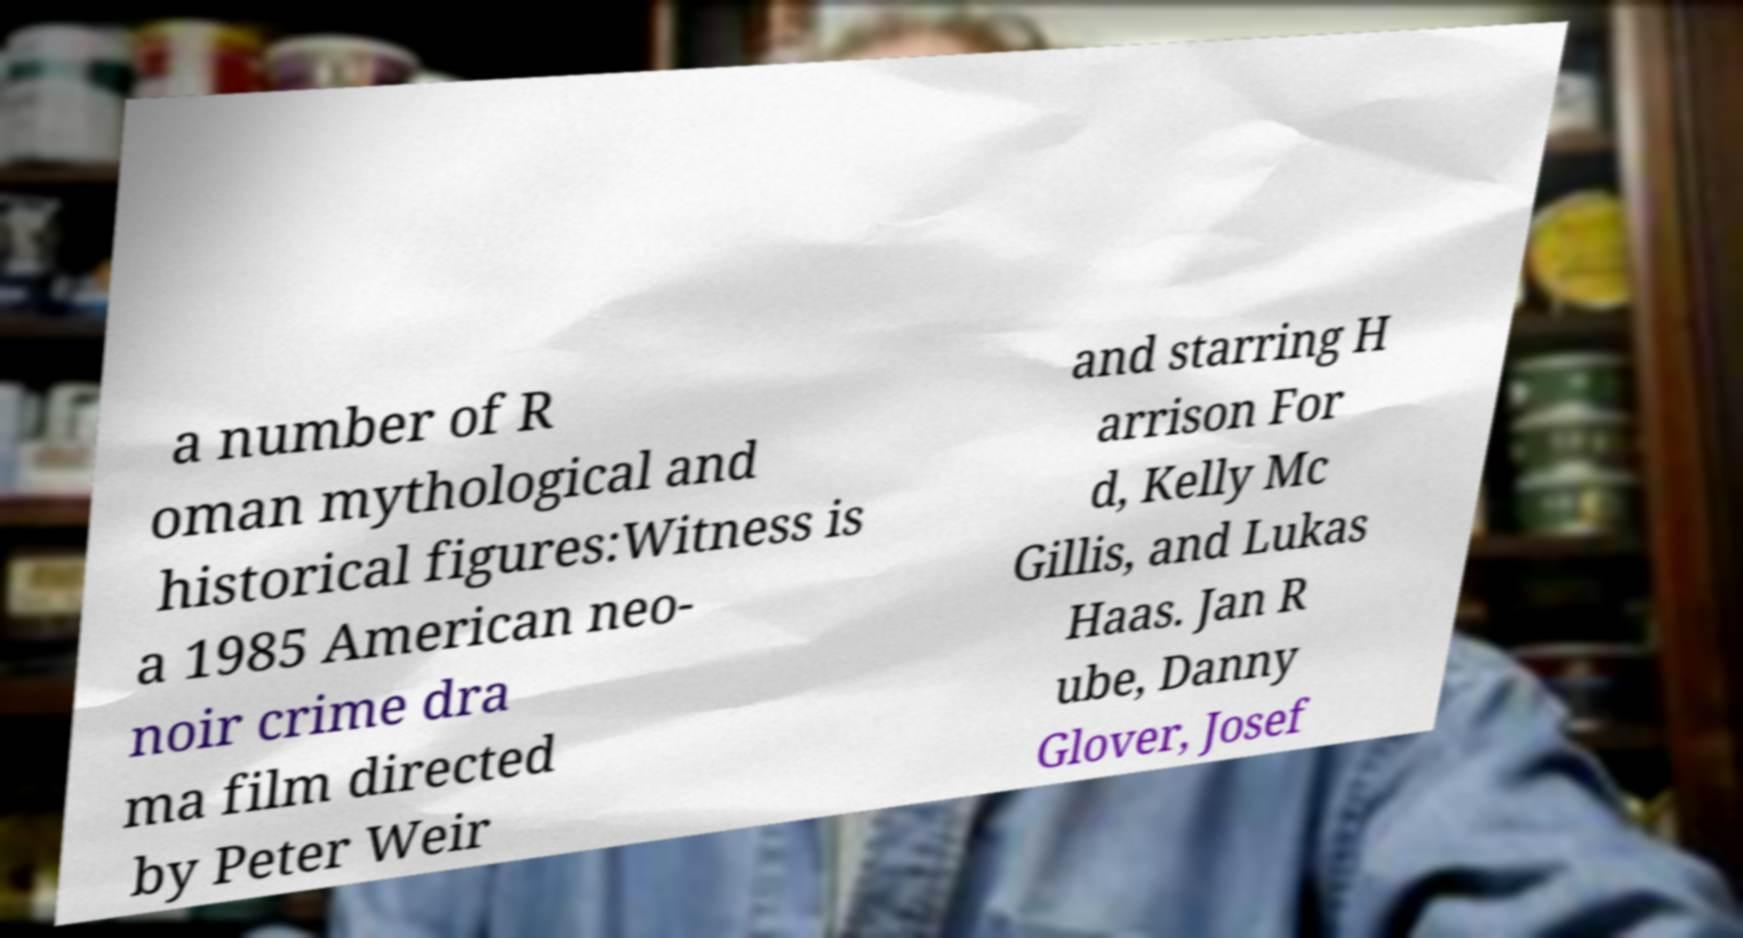Can you accurately transcribe the text from the provided image for me? a number of R oman mythological and historical figures:Witness is a 1985 American neo- noir crime dra ma film directed by Peter Weir and starring H arrison For d, Kelly Mc Gillis, and Lukas Haas. Jan R ube, Danny Glover, Josef 